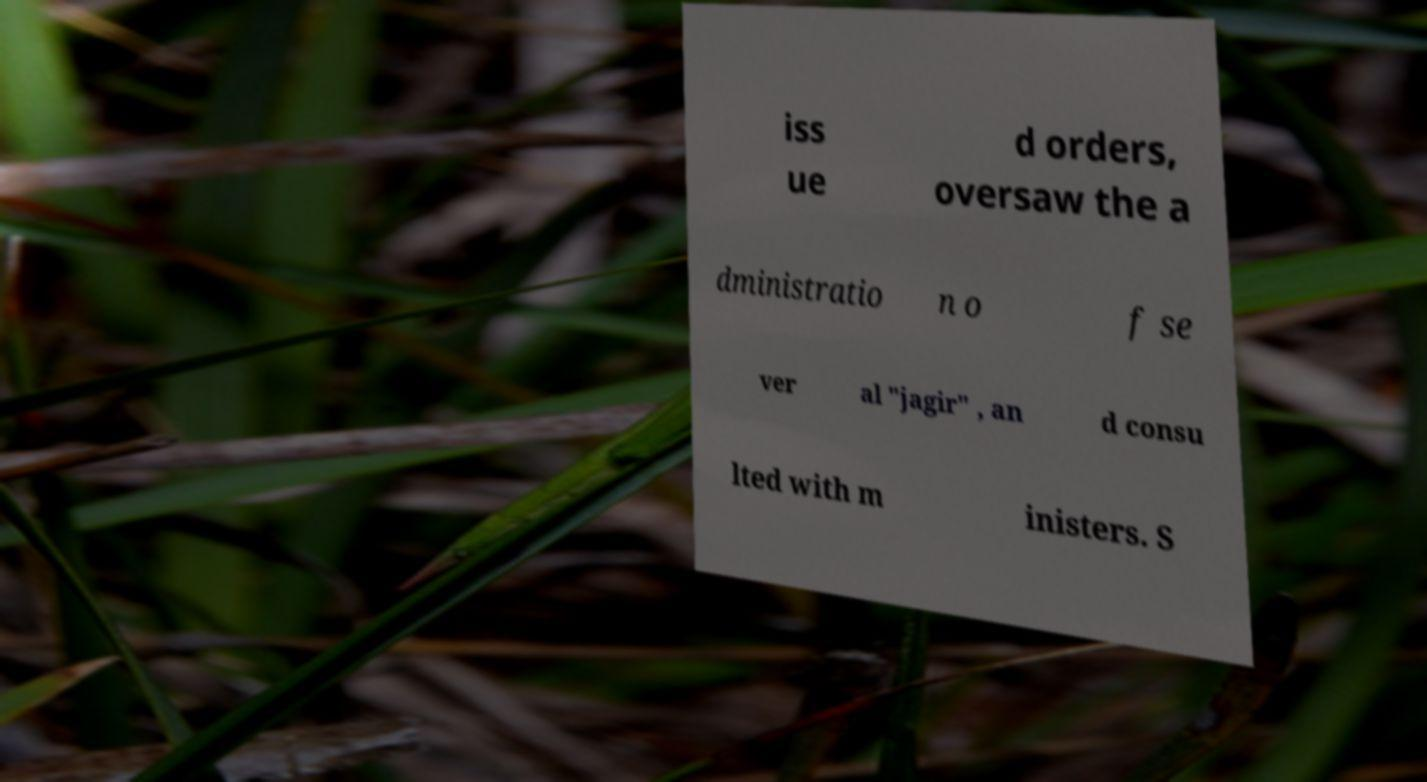There's text embedded in this image that I need extracted. Can you transcribe it verbatim? iss ue d orders, oversaw the a dministratio n o f se ver al "jagir" , an d consu lted with m inisters. S 